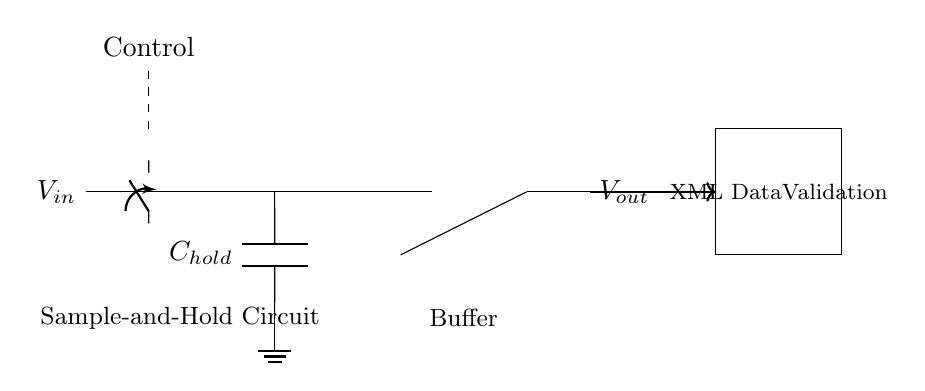What does the component labeled C represent? The component labeled C represents a capacitor used in the sample-and-hold circuit to store the voltage value during the sampling phase.
Answer: Capacitor What is the role of the switch S1? The switch S1 is used to control the sampling process of the analog signal by connecting or disconnecting the input voltage to the capacitor during the sampling phase.
Answer: Control How many operational amplifiers are in this circuit? There is one operational amplifier in the circuit used as a buffer to isolate the output from the capacitor.
Answer: One What is the significance of the output label Vout? The output label Vout represents the voltage that is available after the sample-and-hold process, indicating the stored instantaneous value that can be validated in XML data.
Answer: Validated voltage What is the function of the dashed line labeled Control? The dashed line labeled Control indicates the point at which the control signal activates the switch S1 to start the sampling process in the circuit. This is crucial for determining when to capture the analog signal.
Answer: Control activation What does the rectangular box after Vout signify? The rectangular box signifies the XML Data Validation process that takes the output voltage Vout for further checks against the expected data values.
Answer: XML Validation 